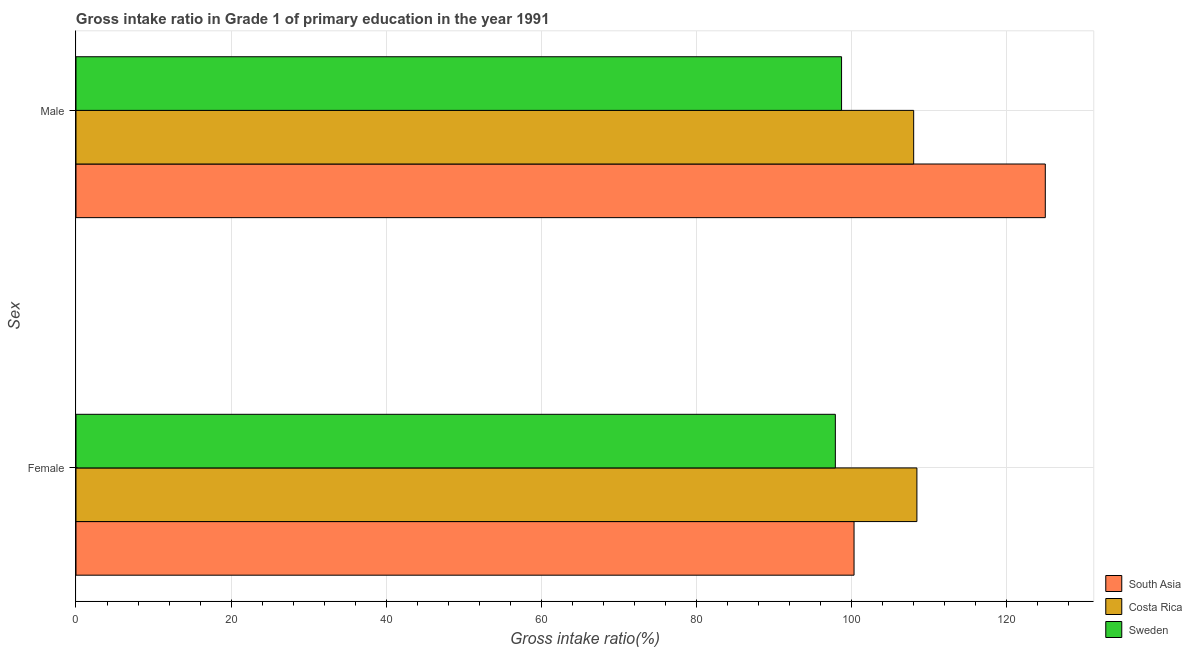How many different coloured bars are there?
Your response must be concise. 3. Are the number of bars per tick equal to the number of legend labels?
Your answer should be very brief. Yes. How many bars are there on the 1st tick from the bottom?
Provide a succinct answer. 3. What is the label of the 1st group of bars from the top?
Give a very brief answer. Male. What is the gross intake ratio(female) in South Asia?
Provide a succinct answer. 100.31. Across all countries, what is the maximum gross intake ratio(male)?
Your answer should be very brief. 124.97. Across all countries, what is the minimum gross intake ratio(female)?
Offer a terse response. 97.9. What is the total gross intake ratio(male) in the graph?
Ensure brevity in your answer.  331.67. What is the difference between the gross intake ratio(male) in Costa Rica and that in Sweden?
Give a very brief answer. 9.3. What is the difference between the gross intake ratio(male) in Sweden and the gross intake ratio(female) in South Asia?
Offer a terse response. -1.61. What is the average gross intake ratio(male) per country?
Provide a short and direct response. 110.56. What is the difference between the gross intake ratio(male) and gross intake ratio(female) in South Asia?
Offer a terse response. 24.66. What is the ratio of the gross intake ratio(male) in South Asia to that in Sweden?
Provide a short and direct response. 1.27. In how many countries, is the gross intake ratio(male) greater than the average gross intake ratio(male) taken over all countries?
Make the answer very short. 1. What does the 2nd bar from the top in Female represents?
Provide a short and direct response. Costa Rica. What does the 1st bar from the bottom in Female represents?
Offer a very short reply. South Asia. Are all the bars in the graph horizontal?
Offer a very short reply. Yes. What is the difference between two consecutive major ticks on the X-axis?
Your answer should be very brief. 20. Are the values on the major ticks of X-axis written in scientific E-notation?
Make the answer very short. No. Does the graph contain any zero values?
Offer a terse response. No. Does the graph contain grids?
Make the answer very short. Yes. Where does the legend appear in the graph?
Your response must be concise. Bottom right. How many legend labels are there?
Offer a terse response. 3. What is the title of the graph?
Provide a succinct answer. Gross intake ratio in Grade 1 of primary education in the year 1991. What is the label or title of the X-axis?
Your response must be concise. Gross intake ratio(%). What is the label or title of the Y-axis?
Ensure brevity in your answer.  Sex. What is the Gross intake ratio(%) of South Asia in Female?
Provide a succinct answer. 100.31. What is the Gross intake ratio(%) in Costa Rica in Female?
Your answer should be very brief. 108.41. What is the Gross intake ratio(%) in Sweden in Female?
Offer a terse response. 97.9. What is the Gross intake ratio(%) of South Asia in Male?
Offer a very short reply. 124.97. What is the Gross intake ratio(%) of Costa Rica in Male?
Keep it short and to the point. 108. What is the Gross intake ratio(%) in Sweden in Male?
Provide a short and direct response. 98.7. Across all Sex, what is the maximum Gross intake ratio(%) of South Asia?
Provide a succinct answer. 124.97. Across all Sex, what is the maximum Gross intake ratio(%) of Costa Rica?
Offer a terse response. 108.41. Across all Sex, what is the maximum Gross intake ratio(%) in Sweden?
Make the answer very short. 98.7. Across all Sex, what is the minimum Gross intake ratio(%) in South Asia?
Keep it short and to the point. 100.31. Across all Sex, what is the minimum Gross intake ratio(%) in Costa Rica?
Make the answer very short. 108. Across all Sex, what is the minimum Gross intake ratio(%) in Sweden?
Make the answer very short. 97.9. What is the total Gross intake ratio(%) of South Asia in the graph?
Offer a terse response. 225.28. What is the total Gross intake ratio(%) in Costa Rica in the graph?
Offer a terse response. 216.41. What is the total Gross intake ratio(%) in Sweden in the graph?
Provide a succinct answer. 196.6. What is the difference between the Gross intake ratio(%) of South Asia in Female and that in Male?
Give a very brief answer. -24.66. What is the difference between the Gross intake ratio(%) of Costa Rica in Female and that in Male?
Your response must be concise. 0.42. What is the difference between the Gross intake ratio(%) in Sweden in Female and that in Male?
Your answer should be compact. -0.8. What is the difference between the Gross intake ratio(%) of South Asia in Female and the Gross intake ratio(%) of Costa Rica in Male?
Make the answer very short. -7.69. What is the difference between the Gross intake ratio(%) of South Asia in Female and the Gross intake ratio(%) of Sweden in Male?
Your answer should be very brief. 1.61. What is the difference between the Gross intake ratio(%) of Costa Rica in Female and the Gross intake ratio(%) of Sweden in Male?
Keep it short and to the point. 9.71. What is the average Gross intake ratio(%) of South Asia per Sex?
Make the answer very short. 112.64. What is the average Gross intake ratio(%) of Costa Rica per Sex?
Provide a short and direct response. 108.21. What is the average Gross intake ratio(%) in Sweden per Sex?
Keep it short and to the point. 98.3. What is the difference between the Gross intake ratio(%) in South Asia and Gross intake ratio(%) in Costa Rica in Female?
Keep it short and to the point. -8.1. What is the difference between the Gross intake ratio(%) in South Asia and Gross intake ratio(%) in Sweden in Female?
Your answer should be compact. 2.41. What is the difference between the Gross intake ratio(%) of Costa Rica and Gross intake ratio(%) of Sweden in Female?
Provide a succinct answer. 10.51. What is the difference between the Gross intake ratio(%) in South Asia and Gross intake ratio(%) in Costa Rica in Male?
Give a very brief answer. 16.97. What is the difference between the Gross intake ratio(%) in South Asia and Gross intake ratio(%) in Sweden in Male?
Offer a very short reply. 26.27. What is the difference between the Gross intake ratio(%) of Costa Rica and Gross intake ratio(%) of Sweden in Male?
Give a very brief answer. 9.3. What is the ratio of the Gross intake ratio(%) of South Asia in Female to that in Male?
Your answer should be very brief. 0.8. What is the difference between the highest and the second highest Gross intake ratio(%) of South Asia?
Your answer should be compact. 24.66. What is the difference between the highest and the second highest Gross intake ratio(%) of Costa Rica?
Give a very brief answer. 0.42. What is the difference between the highest and the second highest Gross intake ratio(%) of Sweden?
Give a very brief answer. 0.8. What is the difference between the highest and the lowest Gross intake ratio(%) of South Asia?
Your answer should be compact. 24.66. What is the difference between the highest and the lowest Gross intake ratio(%) of Costa Rica?
Provide a succinct answer. 0.42. What is the difference between the highest and the lowest Gross intake ratio(%) in Sweden?
Ensure brevity in your answer.  0.8. 